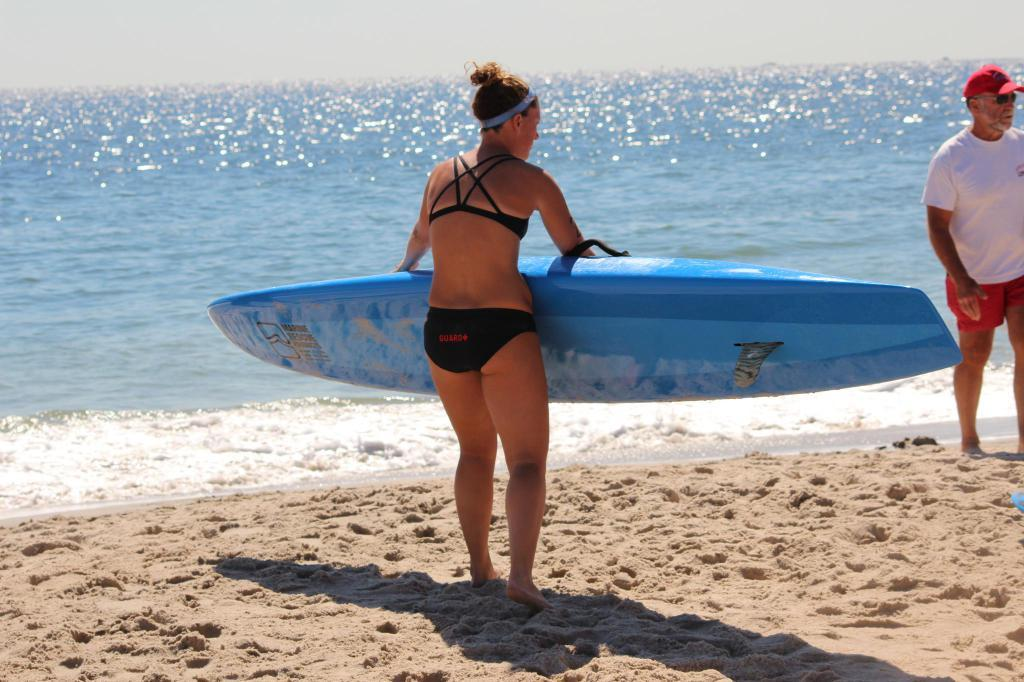Who is present in the image? There is a woman and a man in the image. What is the woman holding in the image? The woman is holding a skateboard. What is the man wearing in the image? The man is wearing a cap. What is the man's position in the image? The man is standing on the ground. Where is the image set? The image is set in front of a beach. What word is being shouted by the man in the image? There is no indication in the image that the man is shouting or saying any specific word. 